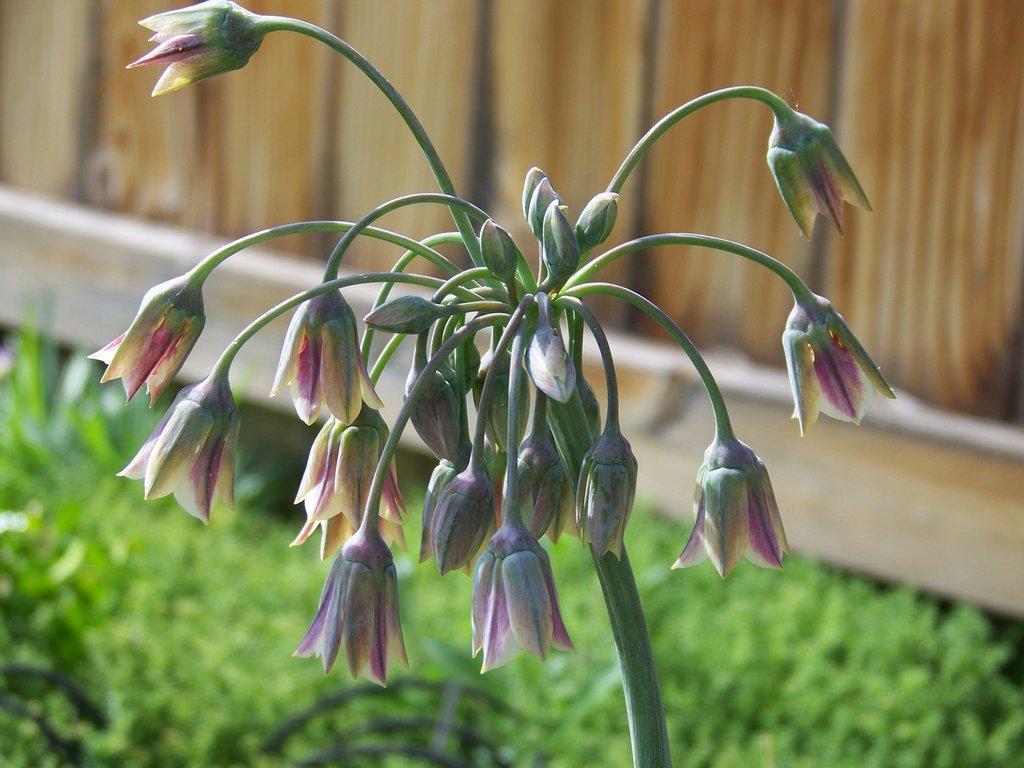Could you give a brief overview of what you see in this image? In this picture we can see a plant, flowers, buds, and grass. In the background we can see a wooden wall. 